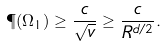<formula> <loc_0><loc_0><loc_500><loc_500>\P ( \Omega _ { 1 } ) \geq \frac { c } { \sqrt { v } } \geq \frac { c } { R ^ { d / 2 } } .</formula> 